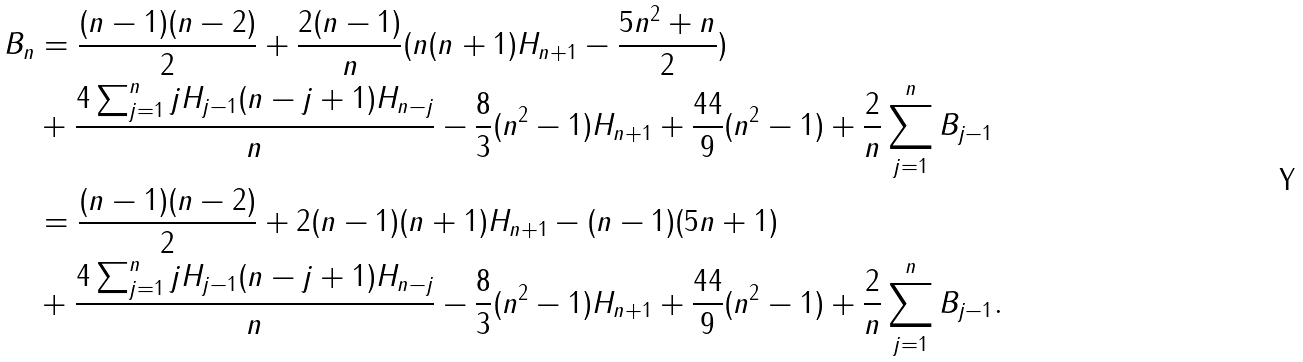Convert formula to latex. <formula><loc_0><loc_0><loc_500><loc_500>B _ { n } & = \frac { ( n - 1 ) ( n - 2 ) } { 2 } + \frac { 2 ( n - 1 ) } { n } ( n ( n + 1 ) H _ { n + 1 } - \frac { 5 n ^ { 2 } + n } { 2 } ) \\ & + \frac { 4 \sum _ { j = 1 } ^ { n } j H _ { j - 1 } ( n - j + 1 ) H _ { n - j } } { n } - \frac { 8 } { 3 } ( n ^ { 2 } - 1 ) H _ { n + 1 } + \frac { 4 4 } { 9 } ( n ^ { 2 } - 1 ) + \frac { 2 } { n } \sum _ { j = 1 } ^ { n } B _ { j - 1 } \\ & = \frac { ( n - 1 ) ( n - 2 ) } { 2 } + 2 ( n - 1 ) ( n + 1 ) H _ { n + 1 } - ( n - 1 ) ( 5 n + 1 ) \\ & + \frac { 4 \sum _ { j = 1 } ^ { n } j H _ { j - 1 } ( n - j + 1 ) H _ { n - j } } { n } - \frac { 8 } { 3 } ( n ^ { 2 } - 1 ) H _ { n + 1 } + \frac { 4 4 } { 9 } ( n ^ { 2 } - 1 ) + \frac { 2 } { n } \sum _ { j = 1 } ^ { n } B _ { j - 1 } .</formula> 